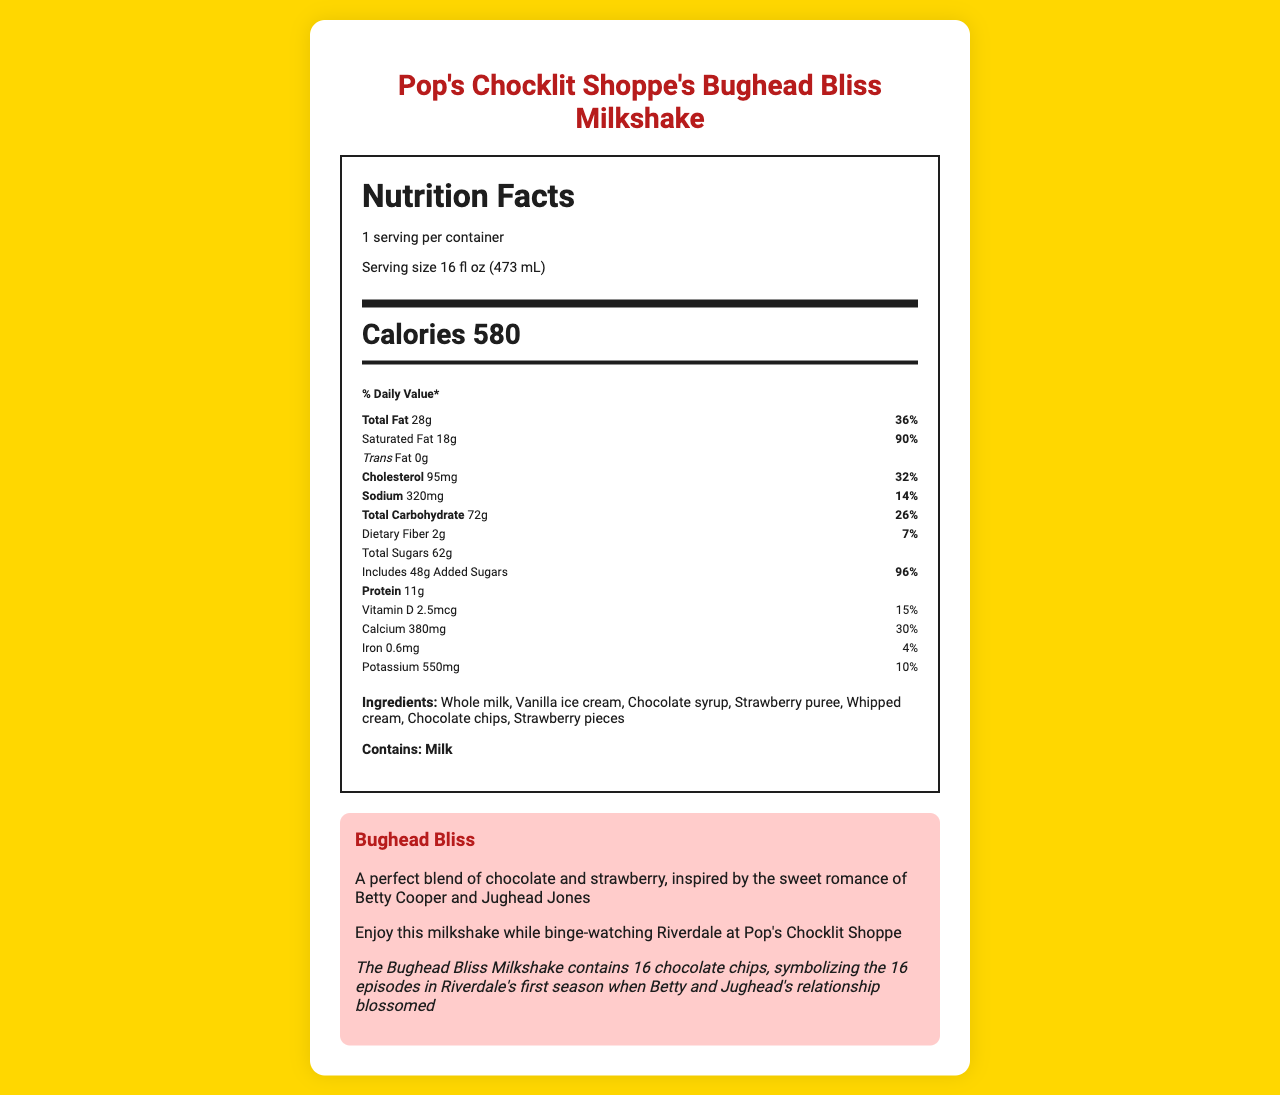What is the serving size of Pop's Chocklit Shoppe's Bughead Bliss Milkshake? The serving size is directly mentioned in the serving info section of the document which indicates "Serving size 16 fl oz (473 mL)".
Answer: 16 fl oz (473 mL) How many calories are there in one serving of the Bughead Bliss Milkshake? The document specifies the calorie content in the calories section as "Calories 580".
Answer: 580 What percentage of the daily value does the total fat content represent? The total fat section specifies the daily value percentage, which is 36%.
Answer: 36% How much added sugar does the Bughead Bliss Milkshake contain? The section on added sugars states "Includes 48 g Added Sugars".
Answer: 48 g Which two ingredients give the Bughead Bliss Milkshake its flavor? According to the ingredients list, "Chocolate syrup" and "Strawberry puree" are used to create the milkshake's flavor.
Answer: Chocolate syrup and Strawberry puree What amount of sodium does the Bughead Bliss Milkshake contain? A. 100 mg B. 320 mg C. 500 mg The nutrient section indicates sodium content as "320 mg".
Answer: B How much protein is in the Bughead Bliss Milkshake? A. 5 g B. 11 g C. 20 g D. 30 g The document specifies the protein content as "11 g".
Answer: B Is the Bughead Bliss Milkshake suitable for someone with a milk allergy? The allergens section clearly states that the milkshake contains "Milk", making it unsuitable for someone with a milk allergy.
Answer: No Can the total carbohydrate content be determined from the document? The total carbohydrate section lists the content as "72 g", making it easily determinable.
Answer: Yes Summarize the main nutritional information of Pop's Chocklit Shoppe's Bughead Bliss Milkshake. This explanation consolidates all key nutritional information from the document into a comprehensive summary.
Answer: The Bughead Bliss Milkshake has 580 calories per serving size of 16 fl oz (473 mL). It contains 28 g of total fat (36% daily value), 18 g of saturated fat (90% daily value), 0 g of trans fat, 95 mg of cholesterol (32% daily value), 320 mg of sodium (14% daily value), 72 g total carbohydrates (26% daily value) including 2 g of dietary fiber (7% daily value) and 62 g total sugars with 48 g as added sugar (96% daily value). Protein content is 11 g, and it also provides 15% daily value of Vitamin D, 30% of Calcium, and 10% of Potassium. The milkshake contains milk as an allergen and features ingredients like whole milk, vanilla ice cream, and chocolate syrup. What was Jughead's favorite topping on his milkshake? The document does not provide any information about Jughead's personal preferences for milkshake toppings, which are unrelated to the nutritional facts provided.
Answer: Not enough information 